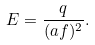Convert formula to latex. <formula><loc_0><loc_0><loc_500><loc_500>E = \frac { q } { ( a f ) ^ { 2 } } .</formula> 